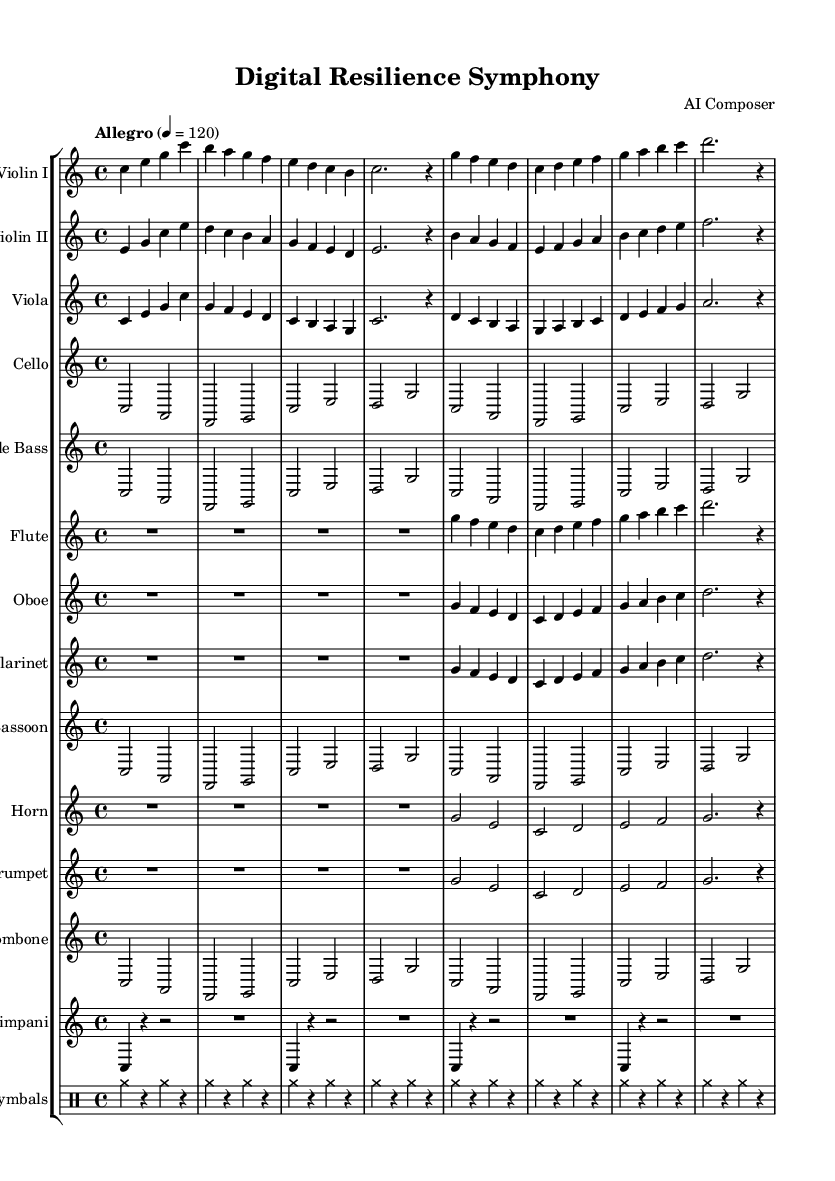What is the key signature of this music? The key signature is shown before the staff, and in this piece, it indicates no sharps or flats, representing C major.
Answer: C major What is the time signature of the piece? The time signature is located at the beginning of the score and in this case, it is 4/4, indicating four beats per measure.
Answer: 4/4 What is the tempo marking of this symphony? The tempo marking appears at the beginning of the score, indicating the speed of the music. Here, it indicates "Allegro" with a metronome marking of quarter note equals 120.
Answer: Allegro How many measures are in the first violin part? By counting the number of vertical lines that separate the music into measures in the Violin I part, I can determine there are 8 measures.
Answer: 8 Which instruments have a similar melodic line in the first section? Both Violin I and Violin II have similar melodic movements utilizing the same rhythms and note sequences in the first section, indicating they often mirror each other.
Answer: Violin I and Violin II What is the highest pitch instrument in this symphony? By comparing the range of the instruments, the flute typically has a higher pitch than others, making it the highest in this symphony.
Answer: Flute What rhythmic pattern is used in the timpani section? The timpani section consists of repetitive quarter notes followed by rests, creating a consistent rhythm pattern throughout the passage.
Answer: Quarter notes and rests 